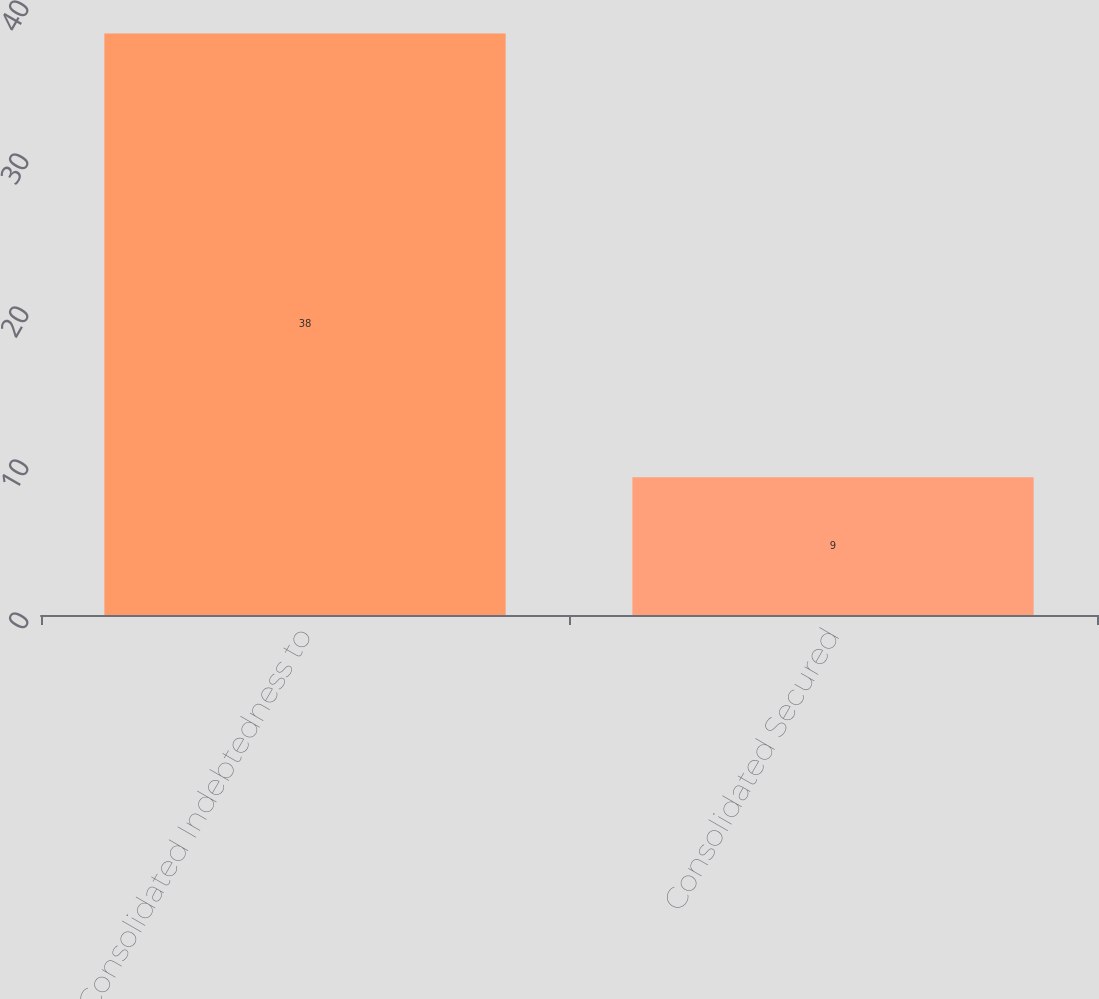Convert chart to OTSL. <chart><loc_0><loc_0><loc_500><loc_500><bar_chart><fcel>Consolidated Indebtedness to<fcel>Consolidated Secured<nl><fcel>38<fcel>9<nl></chart> 